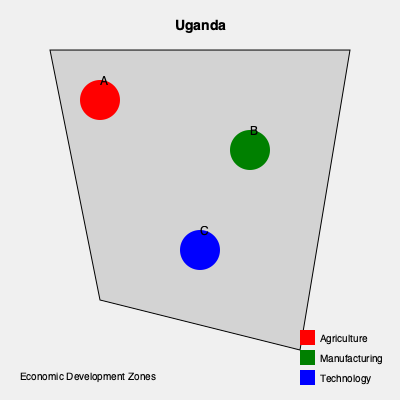Based on the map of Uganda showing potential economic development zones, which zone is best positioned to leverage existing infrastructure and proximity to major urban centers for technology-based initiatives? To answer this question, we need to analyze the map and consider the following factors:

1. The map shows three potential economic development zones: A (red), B (green), and C (blue).

2. Each zone is represented by a colored circle, with the legend indicating:
   - Red: Agriculture
   - Green: Manufacturing
   - Blue: Technology

3. When considering technology-based initiatives, we should look for:
   a) Central location for easier access and distribution
   b) Proximity to urban centers, which usually have better infrastructure and a skilled workforce

4. Analyzing the zones:
   - Zone A (red) is in the northwest, likely far from major urban centers
   - Zone B (green) is in the northeast, also potentially distant from urban areas
   - Zone C (blue) is centrally located, suggesting it might be closer to major cities

5. The blue zone (C) is specifically designated for technology, aligning with the question's focus on technology-based initiatives.

6. Its central location implies better connectivity to other parts of the country, which is crucial for technology development and distribution.

Given these factors, Zone C (blue) appears to be the best positioned for technology-based initiatives, leveraging existing infrastructure and proximity to major urban centers.
Answer: Zone C (blue) 